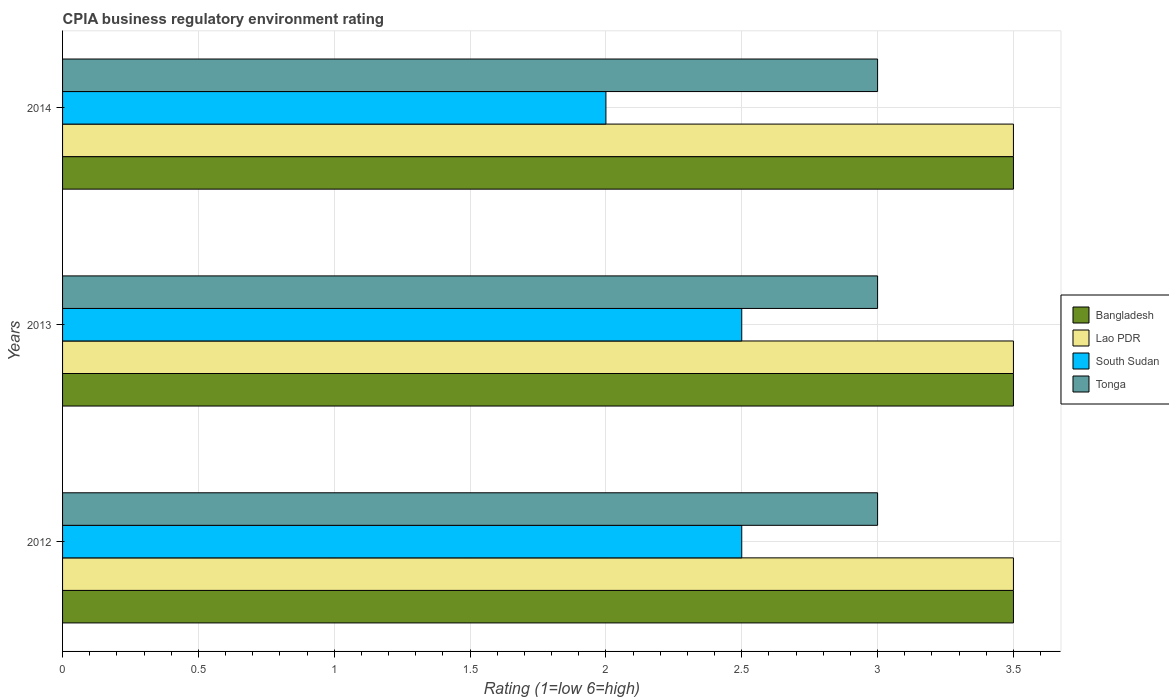How many different coloured bars are there?
Ensure brevity in your answer.  4. Are the number of bars per tick equal to the number of legend labels?
Provide a short and direct response. Yes. Are the number of bars on each tick of the Y-axis equal?
Keep it short and to the point. Yes. What is the label of the 3rd group of bars from the top?
Make the answer very short. 2012. In how many cases, is the number of bars for a given year not equal to the number of legend labels?
Offer a very short reply. 0. Across all years, what is the maximum CPIA rating in South Sudan?
Make the answer very short. 2.5. Across all years, what is the minimum CPIA rating in Tonga?
Provide a succinct answer. 3. What is the difference between the CPIA rating in Lao PDR in 2013 and the CPIA rating in Bangladesh in 2012?
Your response must be concise. 0. In the year 2012, what is the difference between the CPIA rating in Lao PDR and CPIA rating in Tonga?
Give a very brief answer. 0.5. What is the ratio of the CPIA rating in South Sudan in 2012 to that in 2014?
Ensure brevity in your answer.  1.25. Is the CPIA rating in Lao PDR in 2012 less than that in 2014?
Give a very brief answer. No. Is the difference between the CPIA rating in Lao PDR in 2013 and 2014 greater than the difference between the CPIA rating in Tonga in 2013 and 2014?
Offer a very short reply. No. What is the difference between the highest and the lowest CPIA rating in South Sudan?
Provide a succinct answer. 0.5. Is the sum of the CPIA rating in South Sudan in 2013 and 2014 greater than the maximum CPIA rating in Tonga across all years?
Provide a succinct answer. Yes. What does the 2nd bar from the top in 2014 represents?
Give a very brief answer. South Sudan. What does the 2nd bar from the bottom in 2014 represents?
Your answer should be compact. Lao PDR. Is it the case that in every year, the sum of the CPIA rating in South Sudan and CPIA rating in Tonga is greater than the CPIA rating in Lao PDR?
Provide a short and direct response. Yes. How many bars are there?
Provide a succinct answer. 12. How many years are there in the graph?
Provide a short and direct response. 3. What is the difference between two consecutive major ticks on the X-axis?
Provide a short and direct response. 0.5. Does the graph contain any zero values?
Ensure brevity in your answer.  No. Does the graph contain grids?
Make the answer very short. Yes. Where does the legend appear in the graph?
Your answer should be compact. Center right. What is the title of the graph?
Provide a short and direct response. CPIA business regulatory environment rating. Does "Poland" appear as one of the legend labels in the graph?
Offer a terse response. No. What is the Rating (1=low 6=high) of Bangladesh in 2012?
Offer a very short reply. 3.5. What is the Rating (1=low 6=high) in Lao PDR in 2012?
Give a very brief answer. 3.5. What is the Rating (1=low 6=high) in South Sudan in 2012?
Make the answer very short. 2.5. What is the Rating (1=low 6=high) in Tonga in 2012?
Offer a very short reply. 3. What is the Rating (1=low 6=high) of Bangladesh in 2013?
Provide a short and direct response. 3.5. What is the Rating (1=low 6=high) in Tonga in 2013?
Offer a very short reply. 3. Across all years, what is the maximum Rating (1=low 6=high) of Bangladesh?
Your response must be concise. 3.5. Across all years, what is the maximum Rating (1=low 6=high) of Tonga?
Offer a very short reply. 3. Across all years, what is the minimum Rating (1=low 6=high) in Bangladesh?
Your answer should be compact. 3.5. Across all years, what is the minimum Rating (1=low 6=high) of Lao PDR?
Your answer should be very brief. 3.5. Across all years, what is the minimum Rating (1=low 6=high) of Tonga?
Your response must be concise. 3. What is the total Rating (1=low 6=high) of Bangladesh in the graph?
Give a very brief answer. 10.5. What is the total Rating (1=low 6=high) of Lao PDR in the graph?
Ensure brevity in your answer.  10.5. What is the total Rating (1=low 6=high) of South Sudan in the graph?
Your response must be concise. 7. What is the total Rating (1=low 6=high) in Tonga in the graph?
Offer a terse response. 9. What is the difference between the Rating (1=low 6=high) of Lao PDR in 2012 and that in 2013?
Your answer should be very brief. 0. What is the difference between the Rating (1=low 6=high) of South Sudan in 2012 and that in 2013?
Give a very brief answer. 0. What is the difference between the Rating (1=low 6=high) in Tonga in 2012 and that in 2013?
Keep it short and to the point. 0. What is the difference between the Rating (1=low 6=high) of South Sudan in 2012 and that in 2014?
Offer a terse response. 0.5. What is the difference between the Rating (1=low 6=high) in Bangladesh in 2013 and that in 2014?
Provide a short and direct response. 0. What is the difference between the Rating (1=low 6=high) of Lao PDR in 2013 and that in 2014?
Offer a very short reply. 0. What is the difference between the Rating (1=low 6=high) of South Sudan in 2013 and that in 2014?
Your answer should be very brief. 0.5. What is the difference between the Rating (1=low 6=high) of Tonga in 2013 and that in 2014?
Your answer should be compact. 0. What is the difference between the Rating (1=low 6=high) of South Sudan in 2012 and the Rating (1=low 6=high) of Tonga in 2013?
Your response must be concise. -0.5. What is the difference between the Rating (1=low 6=high) in Bangladesh in 2012 and the Rating (1=low 6=high) in Lao PDR in 2014?
Provide a succinct answer. 0. What is the difference between the Rating (1=low 6=high) in Bangladesh in 2012 and the Rating (1=low 6=high) in South Sudan in 2014?
Ensure brevity in your answer.  1.5. What is the difference between the Rating (1=low 6=high) in Bangladesh in 2012 and the Rating (1=low 6=high) in Tonga in 2014?
Your answer should be very brief. 0.5. What is the difference between the Rating (1=low 6=high) in Lao PDR in 2012 and the Rating (1=low 6=high) in Tonga in 2014?
Make the answer very short. 0.5. What is the difference between the Rating (1=low 6=high) of Bangladesh in 2013 and the Rating (1=low 6=high) of Lao PDR in 2014?
Ensure brevity in your answer.  0. What is the difference between the Rating (1=low 6=high) of Bangladesh in 2013 and the Rating (1=low 6=high) of South Sudan in 2014?
Your answer should be compact. 1.5. What is the difference between the Rating (1=low 6=high) in South Sudan in 2013 and the Rating (1=low 6=high) in Tonga in 2014?
Keep it short and to the point. -0.5. What is the average Rating (1=low 6=high) of Lao PDR per year?
Give a very brief answer. 3.5. What is the average Rating (1=low 6=high) in South Sudan per year?
Provide a short and direct response. 2.33. In the year 2012, what is the difference between the Rating (1=low 6=high) of Bangladesh and Rating (1=low 6=high) of Lao PDR?
Ensure brevity in your answer.  0. In the year 2012, what is the difference between the Rating (1=low 6=high) in Bangladesh and Rating (1=low 6=high) in Tonga?
Provide a succinct answer. 0.5. In the year 2012, what is the difference between the Rating (1=low 6=high) in Lao PDR and Rating (1=low 6=high) in South Sudan?
Ensure brevity in your answer.  1. In the year 2012, what is the difference between the Rating (1=low 6=high) in South Sudan and Rating (1=low 6=high) in Tonga?
Your answer should be very brief. -0.5. In the year 2013, what is the difference between the Rating (1=low 6=high) of Bangladesh and Rating (1=low 6=high) of Lao PDR?
Ensure brevity in your answer.  0. In the year 2013, what is the difference between the Rating (1=low 6=high) in Bangladesh and Rating (1=low 6=high) in Tonga?
Make the answer very short. 0.5. In the year 2013, what is the difference between the Rating (1=low 6=high) of Lao PDR and Rating (1=low 6=high) of Tonga?
Give a very brief answer. 0.5. In the year 2014, what is the difference between the Rating (1=low 6=high) in Bangladesh and Rating (1=low 6=high) in South Sudan?
Offer a terse response. 1.5. In the year 2014, what is the difference between the Rating (1=low 6=high) in Lao PDR and Rating (1=low 6=high) in South Sudan?
Give a very brief answer. 1.5. What is the ratio of the Rating (1=low 6=high) in South Sudan in 2012 to that in 2013?
Ensure brevity in your answer.  1. What is the ratio of the Rating (1=low 6=high) of Tonga in 2012 to that in 2013?
Your answer should be very brief. 1. What is the ratio of the Rating (1=low 6=high) of Bangladesh in 2012 to that in 2014?
Your answer should be compact. 1. What is the ratio of the Rating (1=low 6=high) of Lao PDR in 2012 to that in 2014?
Provide a succinct answer. 1. What is the ratio of the Rating (1=low 6=high) of South Sudan in 2012 to that in 2014?
Keep it short and to the point. 1.25. What is the ratio of the Rating (1=low 6=high) of Lao PDR in 2013 to that in 2014?
Provide a succinct answer. 1. What is the difference between the highest and the second highest Rating (1=low 6=high) in Bangladesh?
Your answer should be very brief. 0. What is the difference between the highest and the second highest Rating (1=low 6=high) of Lao PDR?
Offer a very short reply. 0. What is the difference between the highest and the lowest Rating (1=low 6=high) in Bangladesh?
Your answer should be very brief. 0. What is the difference between the highest and the lowest Rating (1=low 6=high) of Lao PDR?
Provide a short and direct response. 0. What is the difference between the highest and the lowest Rating (1=low 6=high) of South Sudan?
Ensure brevity in your answer.  0.5. What is the difference between the highest and the lowest Rating (1=low 6=high) in Tonga?
Your answer should be compact. 0. 